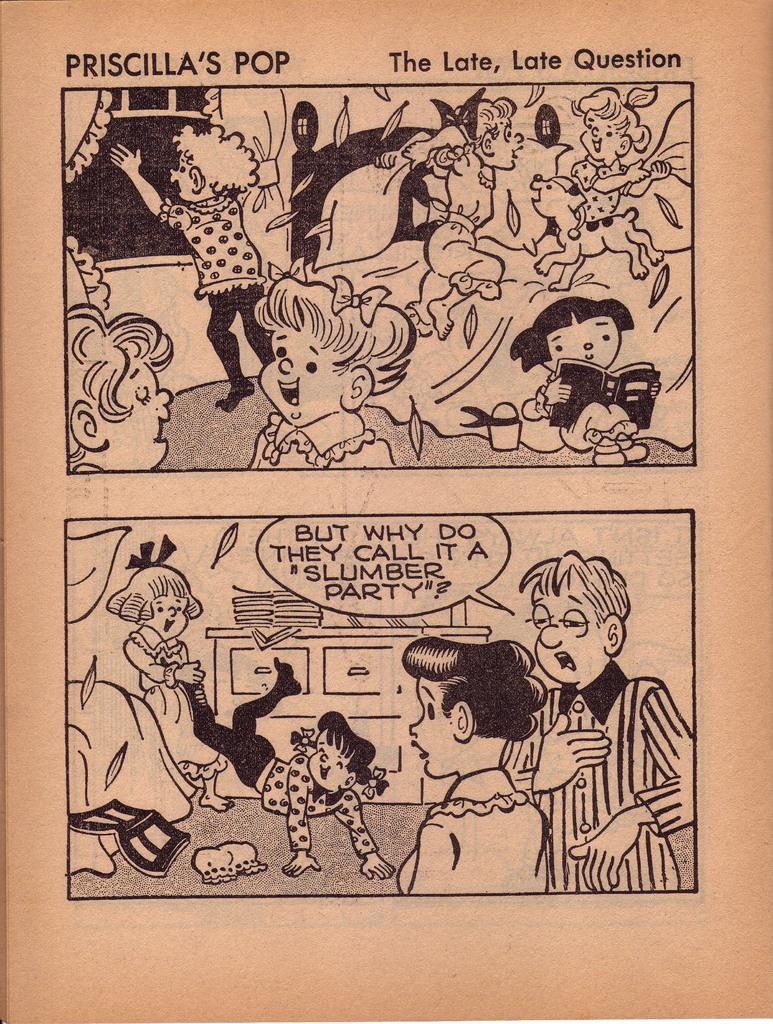<image>
Summarize the visual content of the image. A two block cartoon that is called Priscilla's Pop 